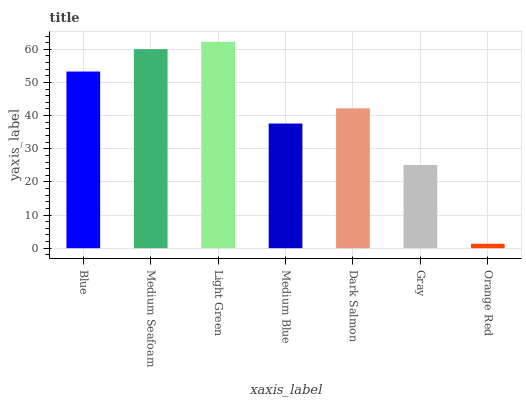Is Medium Seafoam the minimum?
Answer yes or no. No. Is Medium Seafoam the maximum?
Answer yes or no. No. Is Medium Seafoam greater than Blue?
Answer yes or no. Yes. Is Blue less than Medium Seafoam?
Answer yes or no. Yes. Is Blue greater than Medium Seafoam?
Answer yes or no. No. Is Medium Seafoam less than Blue?
Answer yes or no. No. Is Dark Salmon the high median?
Answer yes or no. Yes. Is Dark Salmon the low median?
Answer yes or no. Yes. Is Medium Seafoam the high median?
Answer yes or no. No. Is Blue the low median?
Answer yes or no. No. 